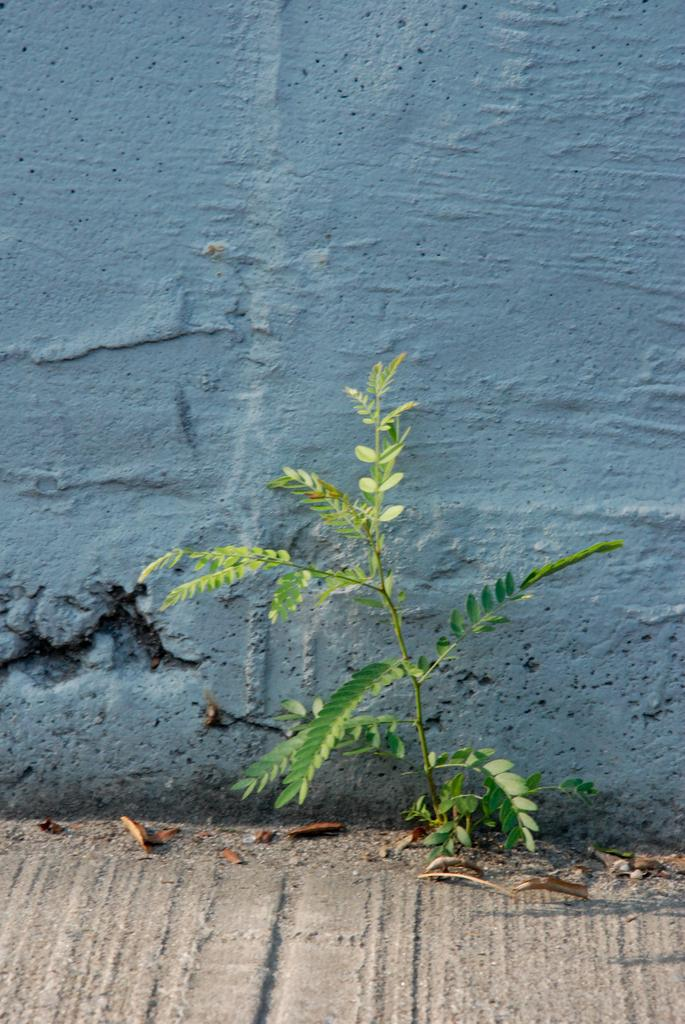What is present in the image? There is a plant in the image. What can be seen on the ground near the plant? There are dried leaves on the ground. What is visible in the background of the image? There is a wall in the background of the image. What type of lunchroom can be seen in the image? There is no lunchroom present in the image. 